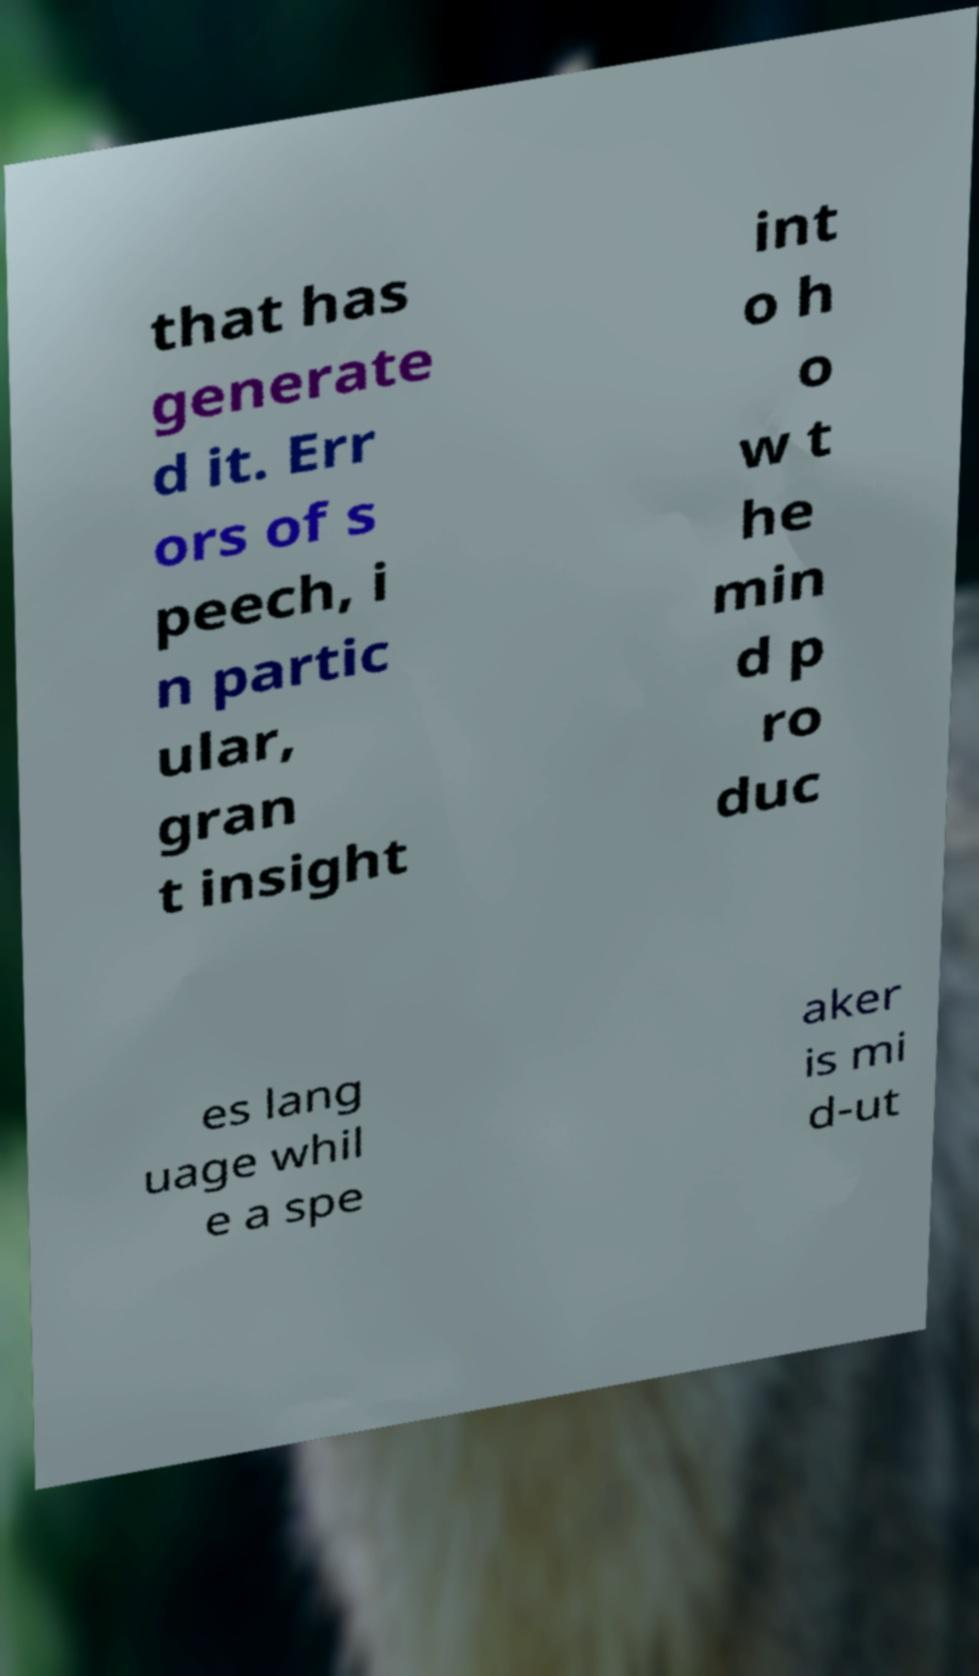I need the written content from this picture converted into text. Can you do that? that has generate d it. Err ors of s peech, i n partic ular, gran t insight int o h o w t he min d p ro duc es lang uage whil e a spe aker is mi d-ut 